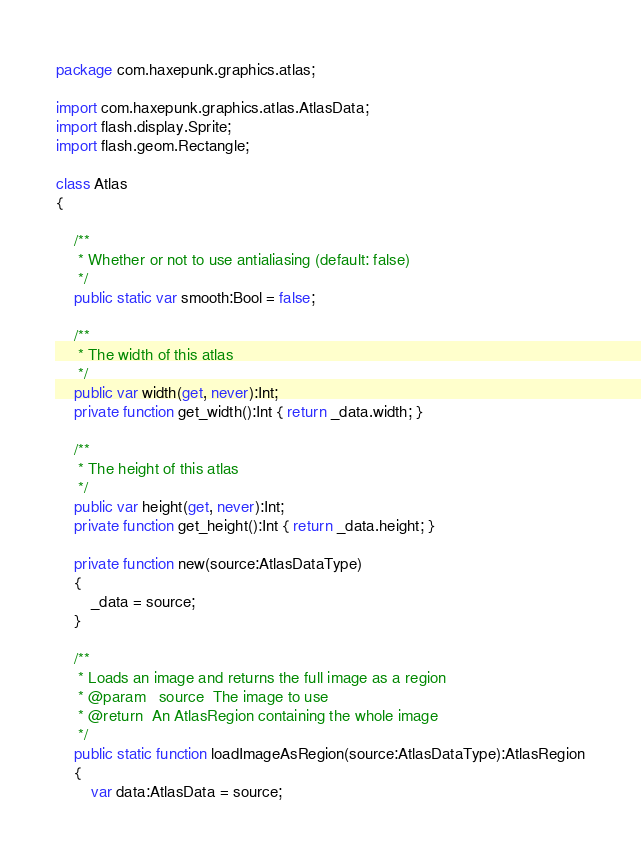Convert code to text. <code><loc_0><loc_0><loc_500><loc_500><_Haxe_>package com.haxepunk.graphics.atlas;

import com.haxepunk.graphics.atlas.AtlasData;
import flash.display.Sprite;
import flash.geom.Rectangle;

class Atlas
{

	/**
	 * Whether or not to use antialiasing (default: false)
	 */
	public static var smooth:Bool = false;

	/**
	 * The width of this atlas
	 */
	public var width(get, never):Int;
	private function get_width():Int { return _data.width; }

	/**
	 * The height of this atlas
	 */
	public var height(get, never):Int;
	private function get_height():Int { return _data.height; }

	private function new(source:AtlasDataType)
	{
		_data = source;
	}

	/**
	 * Loads an image and returns the full image as a region
	 * @param	source	The image to use
	 * @return	An AtlasRegion containing the whole image
	 */
	public static function loadImageAsRegion(source:AtlasDataType):AtlasRegion
	{
		var data:AtlasData = source;</code> 